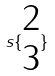<formula> <loc_0><loc_0><loc_500><loc_500>s \{ \begin{matrix} 2 \\ 3 \end{matrix} \}</formula> 